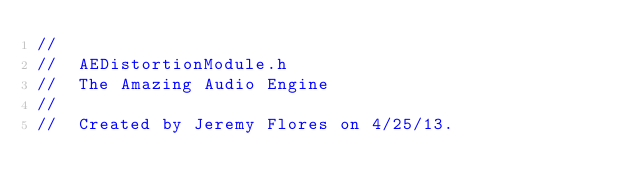Convert code to text. <code><loc_0><loc_0><loc_500><loc_500><_C_>//
//  AEDistortionModule.h
//  The Amazing Audio Engine
//
//  Created by Jeremy Flores on 4/25/13.</code> 